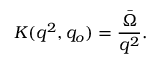<formula> <loc_0><loc_0><loc_500><loc_500>K ( q ^ { 2 } , q _ { o } ) = { \frac { \bar { \Omega } } { q ^ { 2 } } } .</formula> 